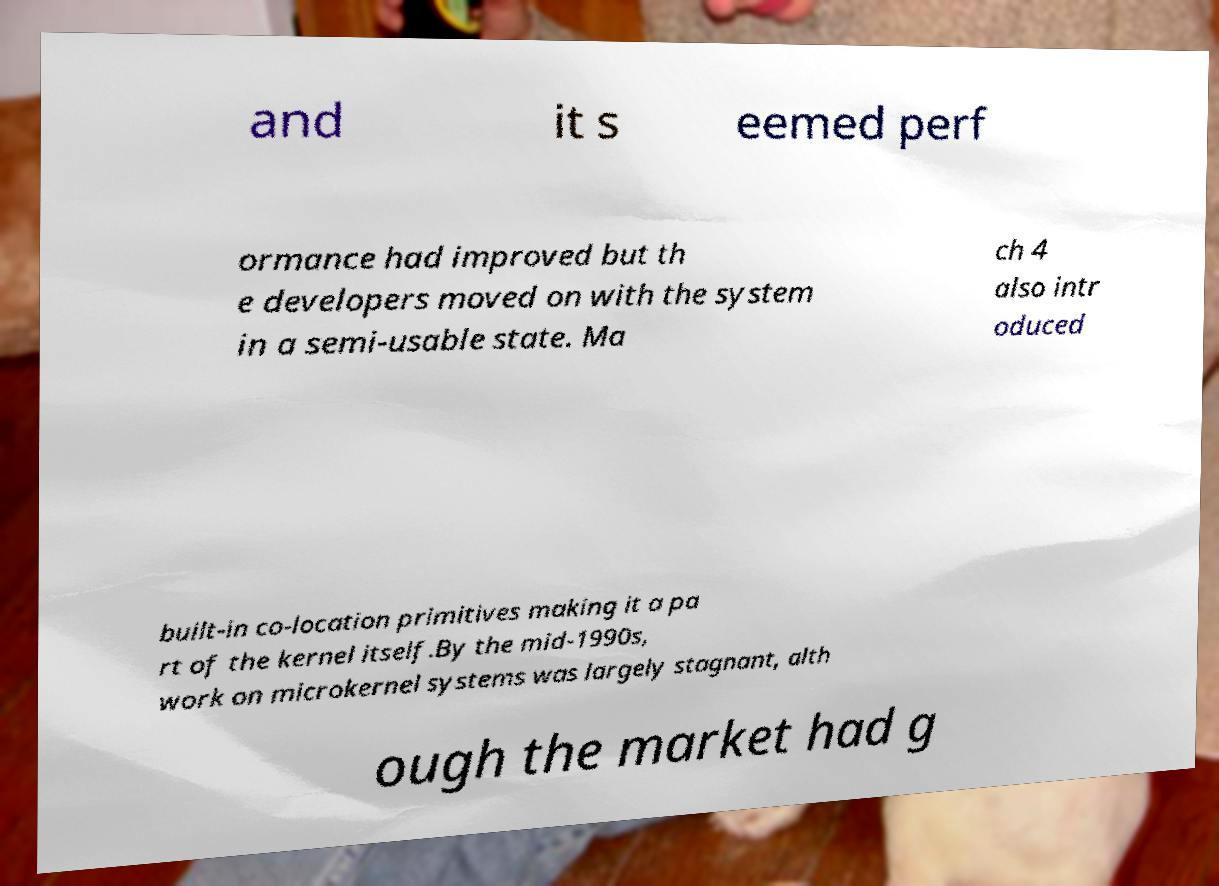Please read and relay the text visible in this image. What does it say? and it s eemed perf ormance had improved but th e developers moved on with the system in a semi-usable state. Ma ch 4 also intr oduced built-in co-location primitives making it a pa rt of the kernel itself.By the mid-1990s, work on microkernel systems was largely stagnant, alth ough the market had g 